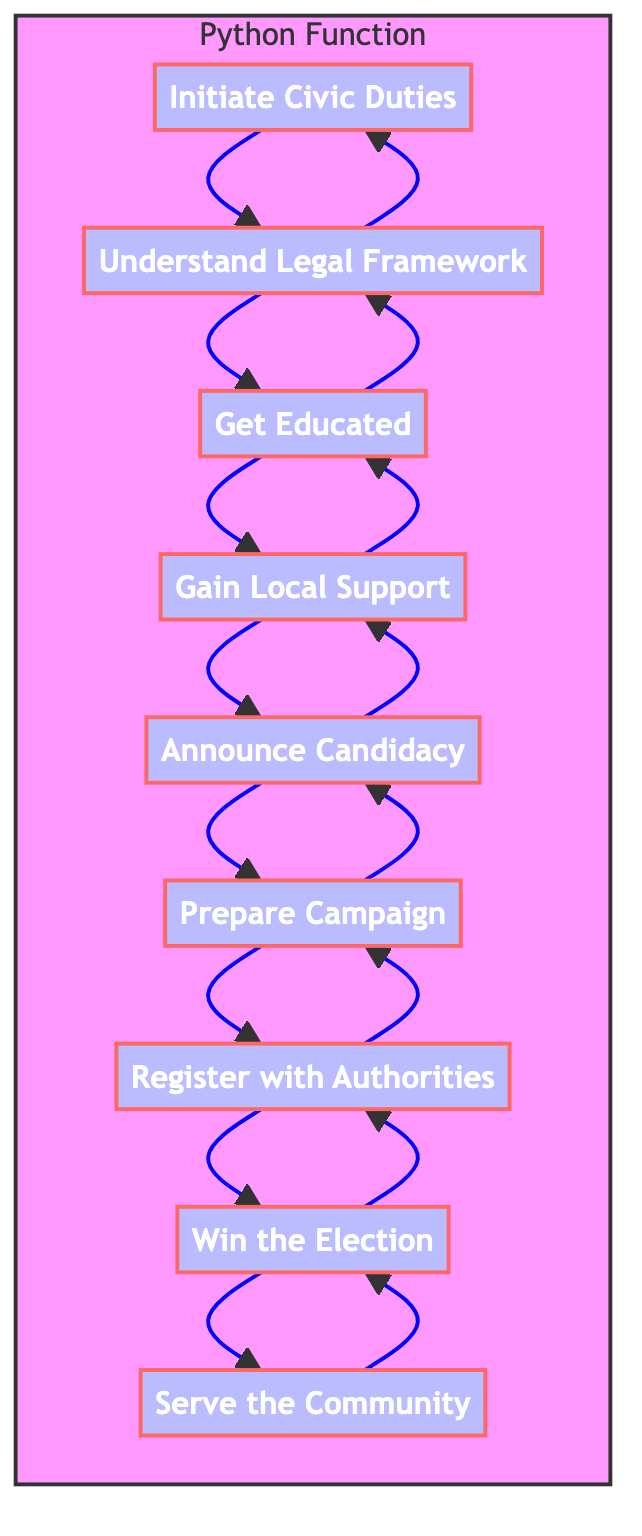What is the first step to becoming a community representative? The first step is "Initiate Civic Duties," which involves starting to engage in community services and local events. This is clearly represented as the bottommost node in the diagram.
Answer: Initiate Civic Duties How many steps are there to become a community representative? The diagram lists a total of nine steps, starting from "Initiate Civic Duties" and ending with "Serve the Community." Counting each step shows this total.
Answer: Nine Which step follows "Prepare Campaign"? According to the flow of the diagram, the step that follows "Prepare Campaign" is "Register with Authorities." This is determined by following the arrows leading from one step to another.
Answer: Register with Authorities What is the last step in the process? The last step in the process is "Serve the Community." This is the topmost step in the flow of the diagram.
Answer: Serve the Community What step comes immediately before "Announce Candidacy"? "Gain Local Support" is the step that comes immediately before "Announce Candidacy," as seen by tracing the flow of steps backwards from "Announce Candidacy."
Answer: Gain Local Support What must a candidate do after winning the election? After winning the election, a candidate must "Serve the Community," which emphasizes their role and responsibility post-election as shown in the diagram.
Answer: Serve the Community Which step requires acquiring education or certifications? The step "Get Educated" directly refers to acquiring necessary education or certifications that can enhance credibility. This is explicitly outlined in the diagram as one of the steps.
Answer: Get Educated How does the diagram represent the flow of a Python Function? The diagram shows the flow of a Python function by depicting steps as nodes and connecting them with arrows indicating the order of operations. The overall structure mimics the flow of function execution from start to finish.
Answer: Flow of Steps 